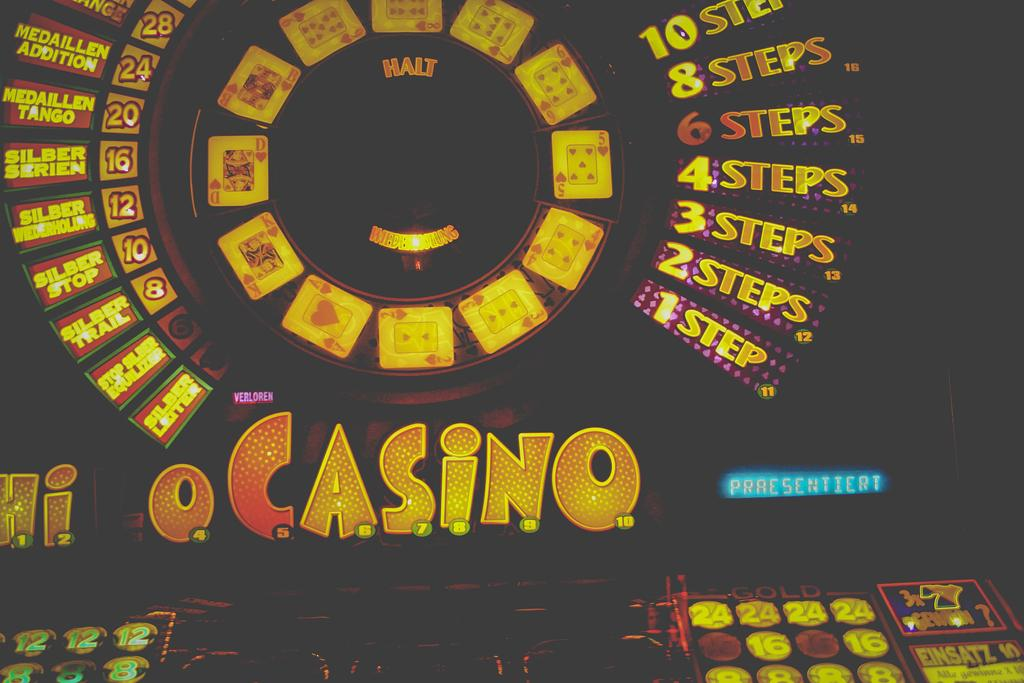<image>
Relay a brief, clear account of the picture shown. a circle full of lights that says '2 steps' on one portion 